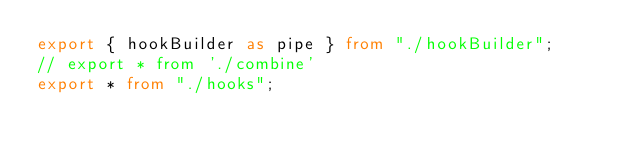Convert code to text. <code><loc_0><loc_0><loc_500><loc_500><_TypeScript_>export { hookBuilder as pipe } from "./hookBuilder";
// export * from './combine'
export * from "./hooks";
</code> 